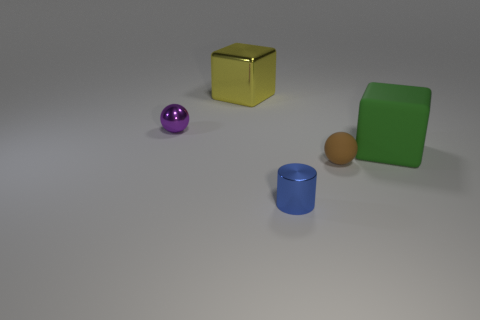Add 1 green blocks. How many objects exist? 6 Subtract all blocks. How many objects are left? 3 Subtract all purple balls. How many gray cylinders are left? 0 Subtract all big rubber objects. Subtract all purple metallic things. How many objects are left? 3 Add 1 green matte cubes. How many green matte cubes are left? 2 Add 4 yellow metal cubes. How many yellow metal cubes exist? 5 Subtract all brown spheres. How many spheres are left? 1 Subtract 0 gray cubes. How many objects are left? 5 Subtract 1 blocks. How many blocks are left? 1 Subtract all gray blocks. Subtract all green balls. How many blocks are left? 2 